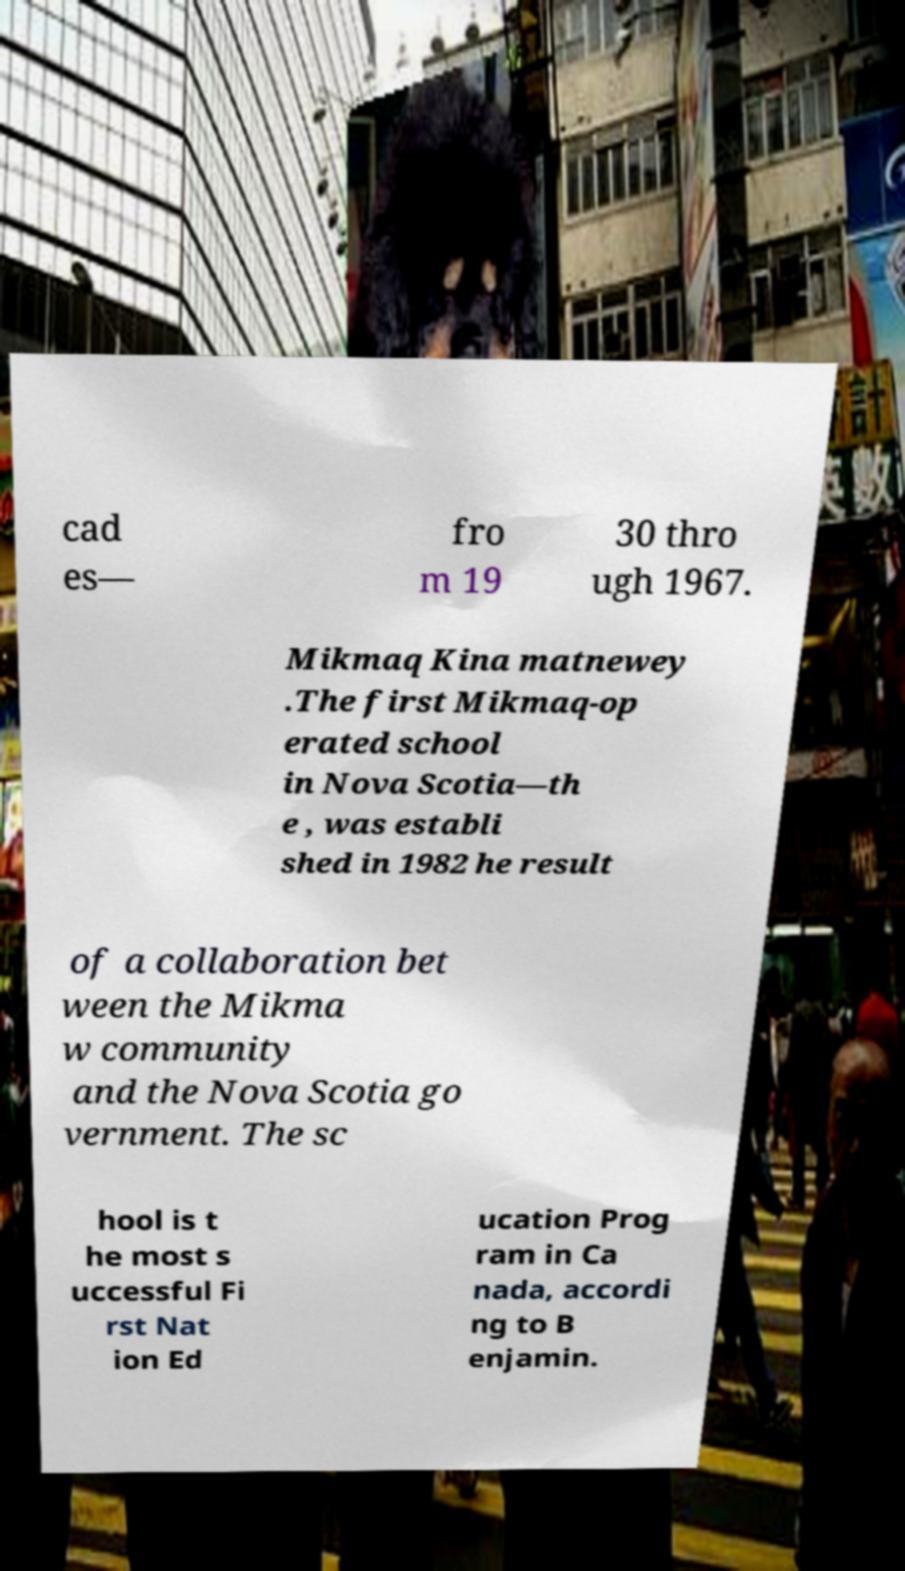What messages or text are displayed in this image? I need them in a readable, typed format. cad es— fro m 19 30 thro ugh 1967. Mikmaq Kina matnewey .The first Mikmaq-op erated school in Nova Scotia—th e , was establi shed in 1982 he result of a collaboration bet ween the Mikma w community and the Nova Scotia go vernment. The sc hool is t he most s uccessful Fi rst Nat ion Ed ucation Prog ram in Ca nada, accordi ng to B enjamin. 